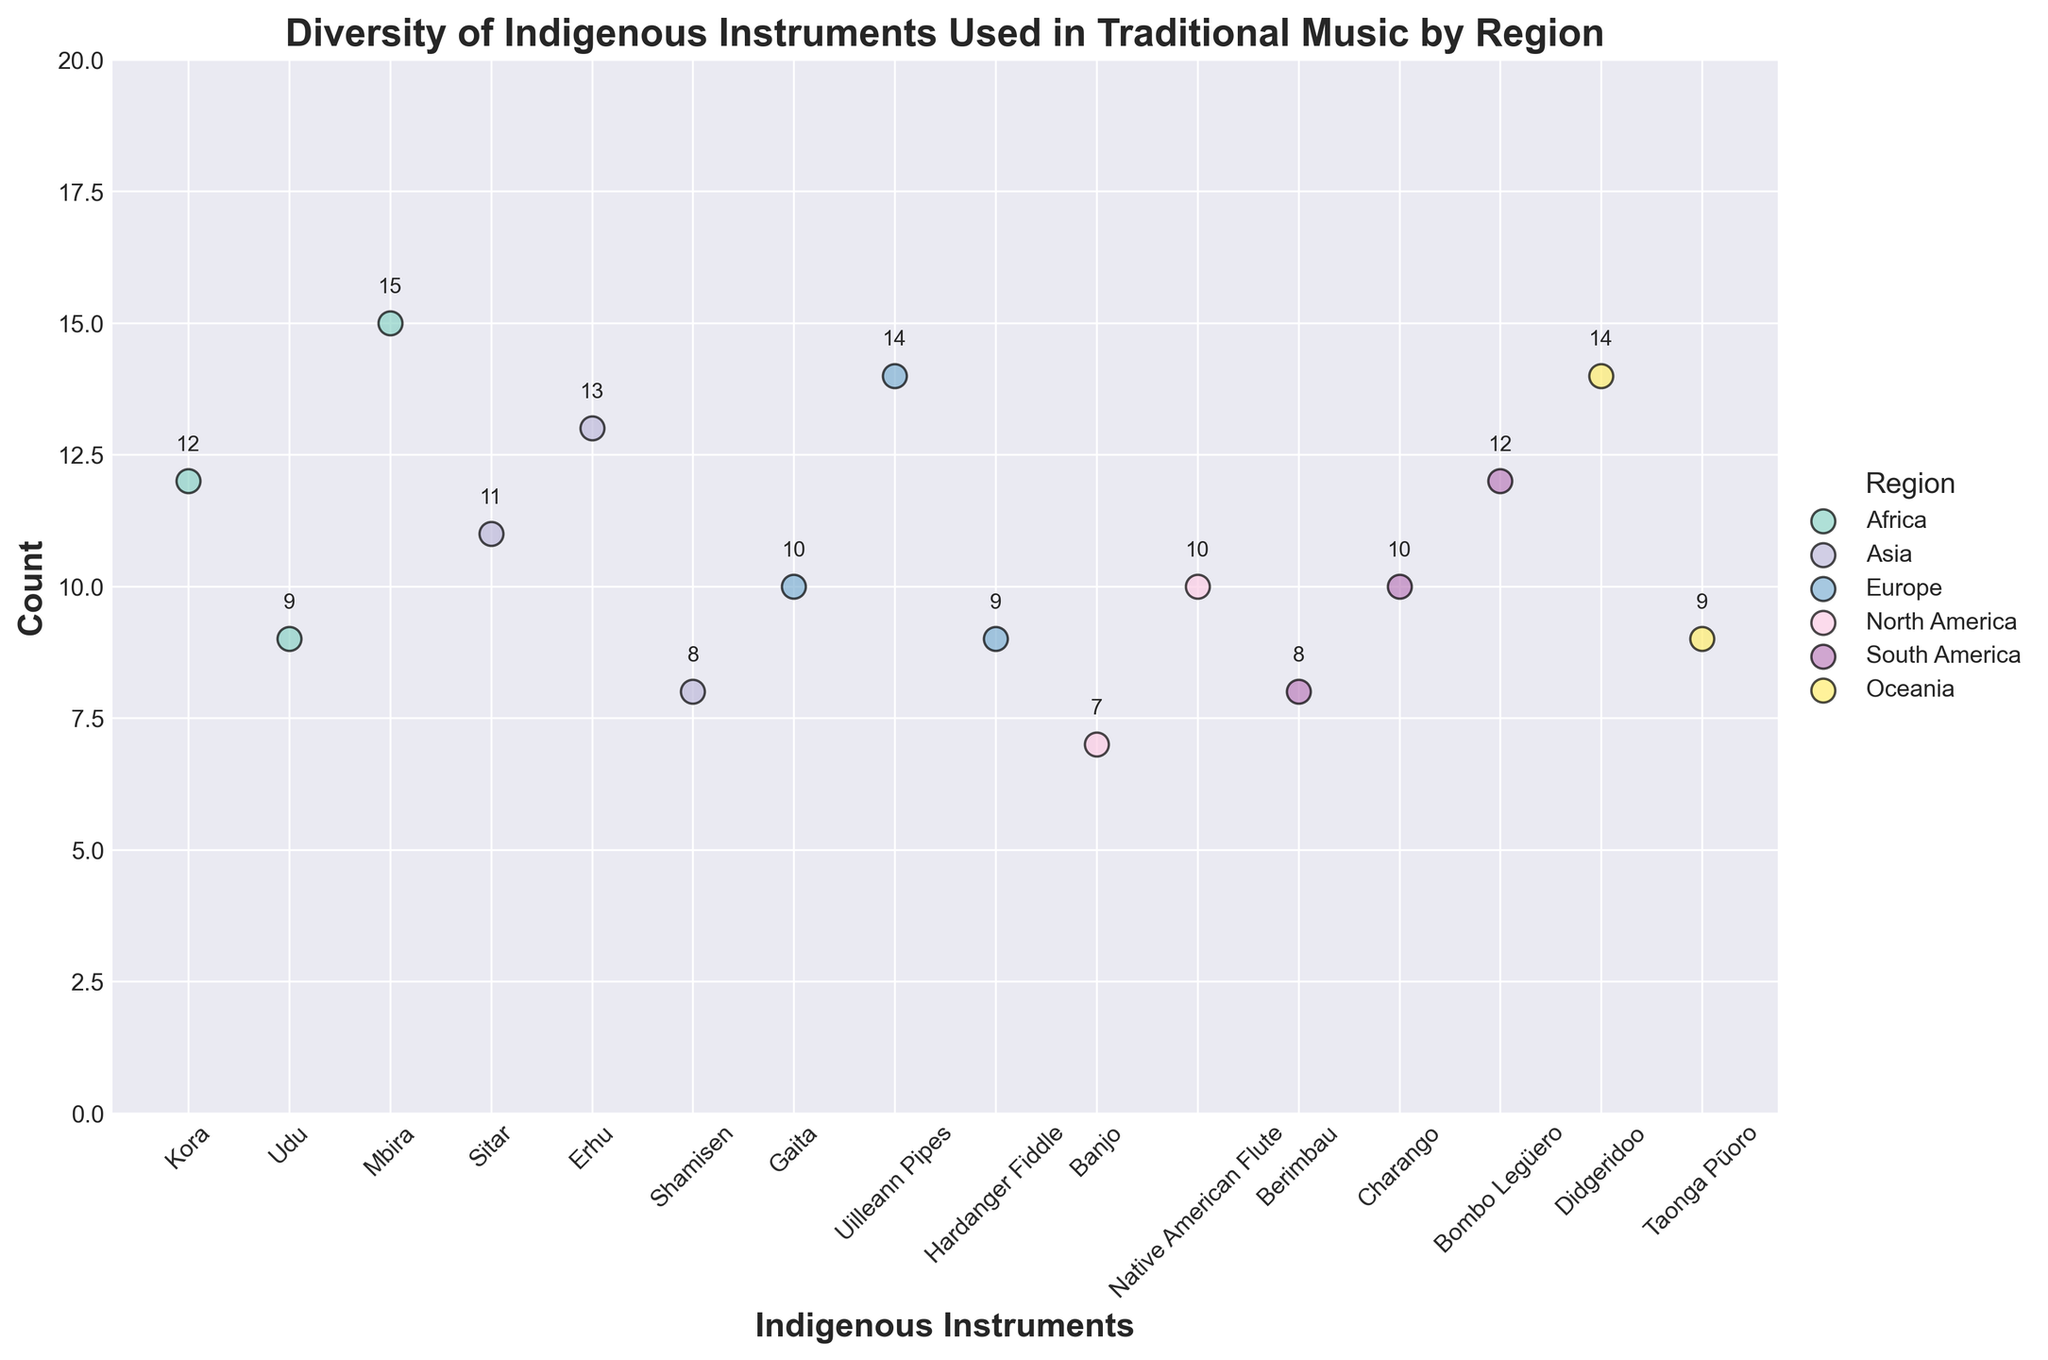Which region has the highest count for any single instrument? By looking at the plot, we can see that the "Mbira" from South Africa has the highest count.
Answer: South Africa What is the average count of instruments in Asia? The counts of instruments in Asia are 11, 13, and 8. The average is calculated as (11 + 13 + 8) / 3 = 10.67.
Answer: 10.67 Which instrument in Europe has the lowest count? By checking the data points, the "Hardanger Fiddle" from Norway has the lowest count of 9 among European instruments.
Answer: Hardanger Fiddle How many instruments are represented in total across all regions? Counting all data points on the scatter plot reveals there are 16 distinct instruments.
Answer: 16 Which region has the most diverse range of indigenous instruments based on the plot? By looking at the number of different instruments per region on the graph, it appears that Asia, Europe, and South America each have three different instruments represented.
Answer: Asia, Europe, South America What is the range of instrument counts in Oceania? The counts in Oceania are 14 and 9. The range is calculated as the difference between the highest and lowest values, which is 14 - 9 = 5.
Answer: 5 Compare the total count of instruments between Africa and North America. Which one is higher? Summing the counts of instruments in Africa (12 + 9 + 15 = 36) and North America (7 + 10 = 17), we see that Africa has a higher total count.
Answer: Africa What is the median count of instruments for South America? The counts for South America are 8, 10, and 12. Arranging them in order, we have 8, 10, 12. The median value is the middle one, which is 10.
Answer: 10 Is there any region where the count for each instrument is below 10? By analyzing the plot, we see that none of the regions have all their instruments with counts below 10.
Answer: No 